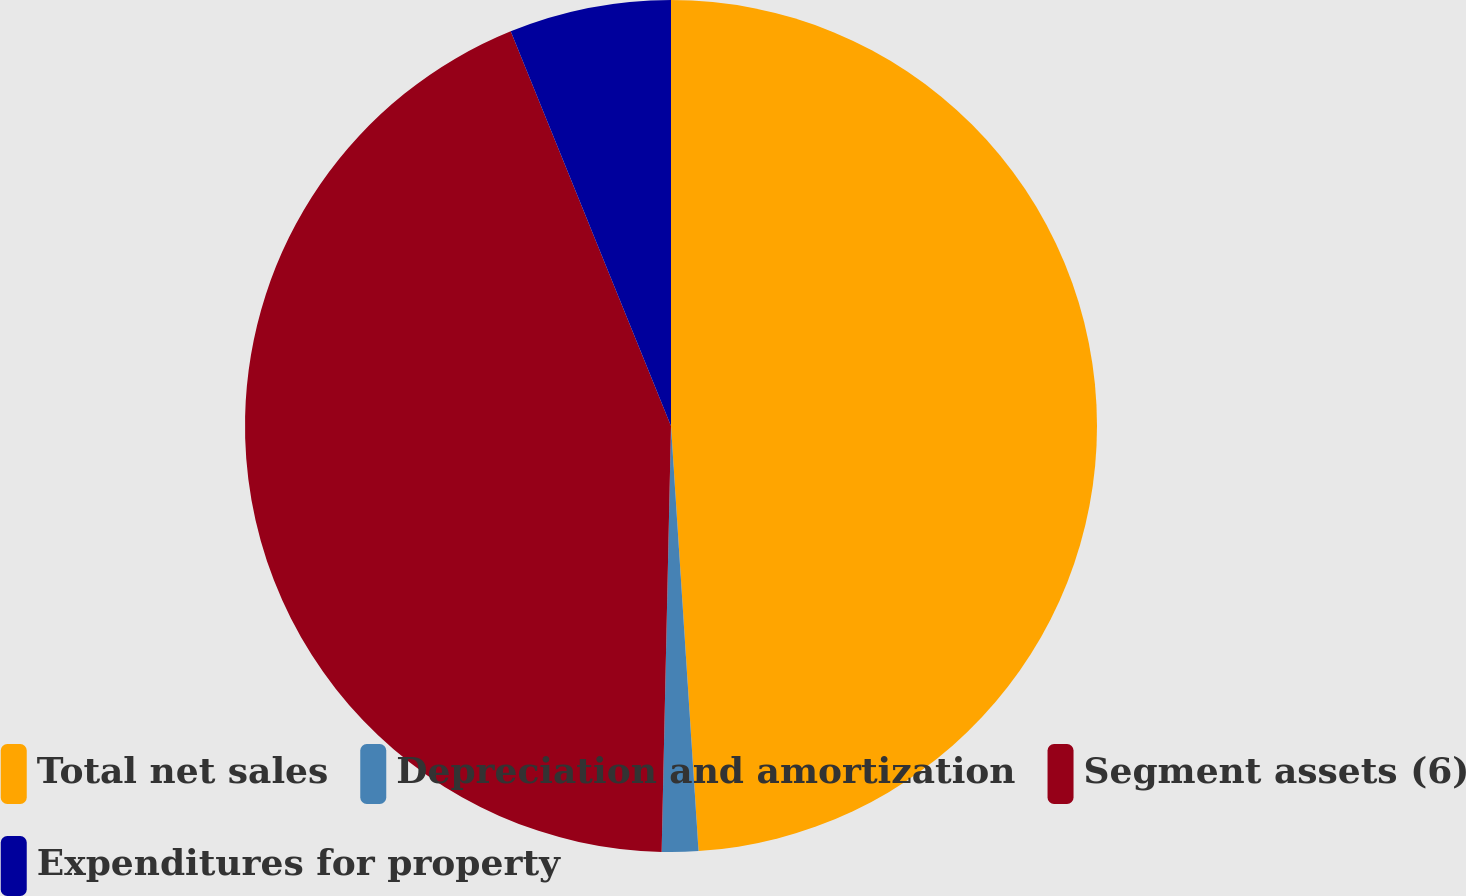<chart> <loc_0><loc_0><loc_500><loc_500><pie_chart><fcel>Total net sales<fcel>Depreciation and amortization<fcel>Segment assets (6)<fcel>Expenditures for property<nl><fcel>48.97%<fcel>1.38%<fcel>43.51%<fcel>6.14%<nl></chart> 